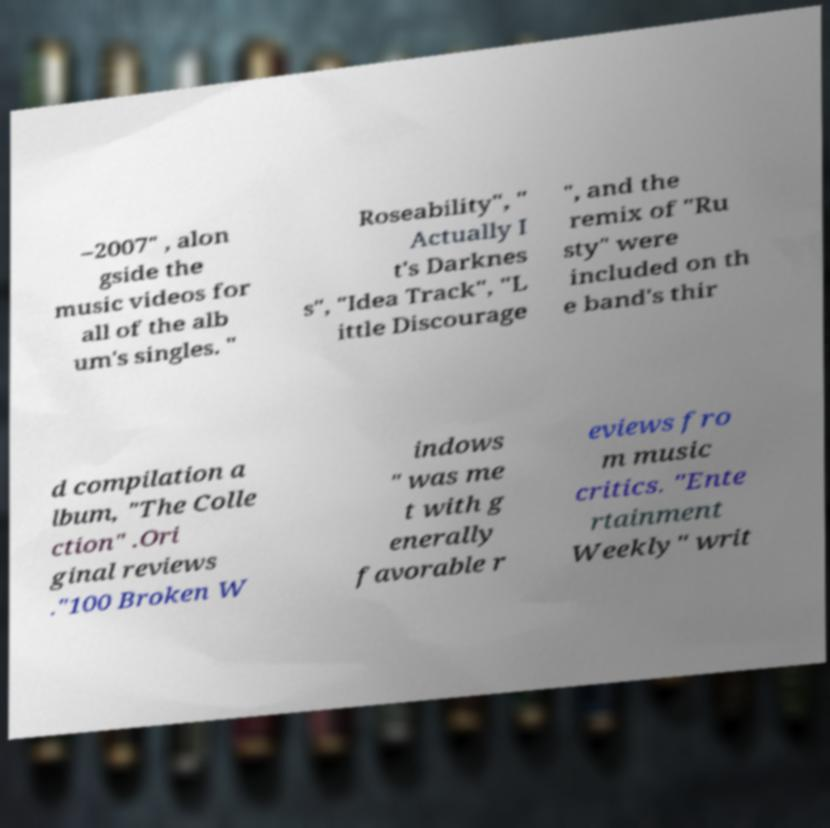Can you accurately transcribe the text from the provided image for me? –2007" , alon gside the music videos for all of the alb um's singles. " Roseability", " Actually I t's Darknes s", "Idea Track", "L ittle Discourage ", and the remix of "Ru sty" were included on th e band's thir d compilation a lbum, "The Colle ction" .Ori ginal reviews ."100 Broken W indows " was me t with g enerally favorable r eviews fro m music critics. "Ente rtainment Weekly" writ 